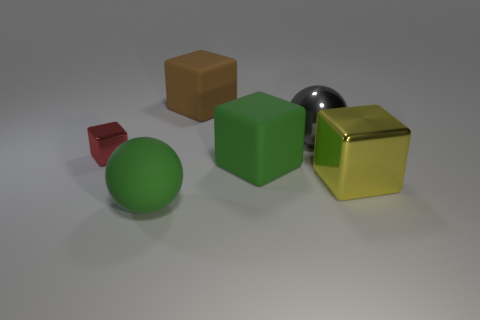Is the number of big gray metallic balls that are in front of the big gray object greater than the number of big matte balls behind the yellow cube?
Give a very brief answer. No. What number of things are big rubber blocks that are in front of the red shiny thing or brown matte blocks?
Offer a terse response. 2. There is a large gray thing that is the same material as the yellow thing; what is its shape?
Provide a succinct answer. Sphere. Is there anything else that has the same shape as the red shiny object?
Your answer should be very brief. Yes. The large rubber thing that is behind the big green matte ball and in front of the large brown object is what color?
Offer a terse response. Green. What number of cubes are either blue matte objects or red things?
Ensure brevity in your answer.  1. What number of other gray things are the same size as the gray thing?
Give a very brief answer. 0. How many big matte objects are left of the ball that is in front of the tiny thing?
Your answer should be very brief. 0. There is a metallic thing that is both on the right side of the large green block and behind the big yellow shiny block; how big is it?
Your response must be concise. Large. Is the number of yellow objects greater than the number of green shiny objects?
Provide a succinct answer. Yes. 